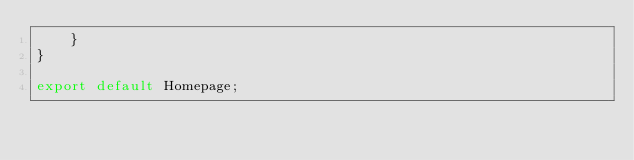<code> <loc_0><loc_0><loc_500><loc_500><_JavaScript_>    }
}

export default Homepage;</code> 